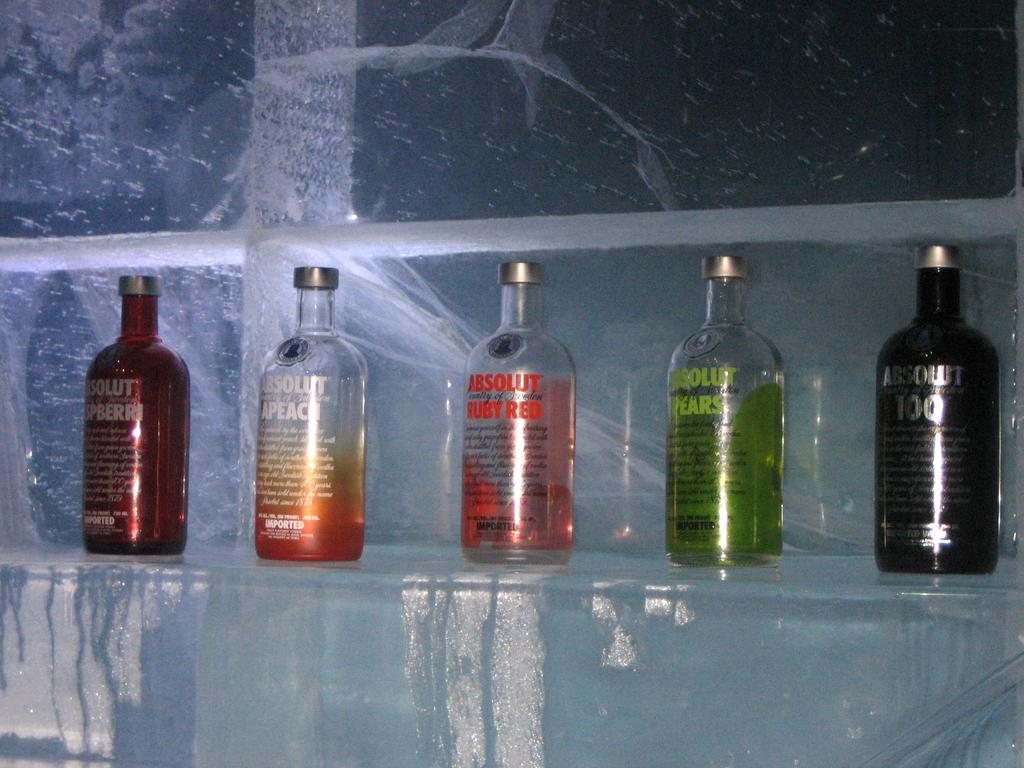<image>
Provide a brief description of the given image. a shelf of different flavors of absolut vodka 